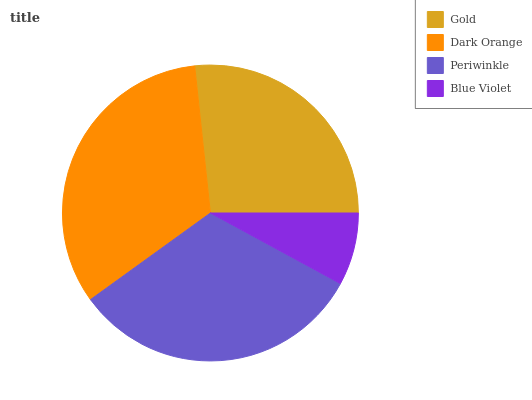Is Blue Violet the minimum?
Answer yes or no. Yes. Is Dark Orange the maximum?
Answer yes or no. Yes. Is Periwinkle the minimum?
Answer yes or no. No. Is Periwinkle the maximum?
Answer yes or no. No. Is Dark Orange greater than Periwinkle?
Answer yes or no. Yes. Is Periwinkle less than Dark Orange?
Answer yes or no. Yes. Is Periwinkle greater than Dark Orange?
Answer yes or no. No. Is Dark Orange less than Periwinkle?
Answer yes or no. No. Is Periwinkle the high median?
Answer yes or no. Yes. Is Gold the low median?
Answer yes or no. Yes. Is Dark Orange the high median?
Answer yes or no. No. Is Blue Violet the low median?
Answer yes or no. No. 